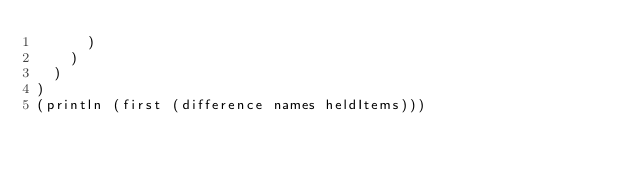Convert code to text. <code><loc_0><loc_0><loc_500><loc_500><_Clojure_>      )
    )
  )
)
(println (first (difference names heldItems)))
</code> 